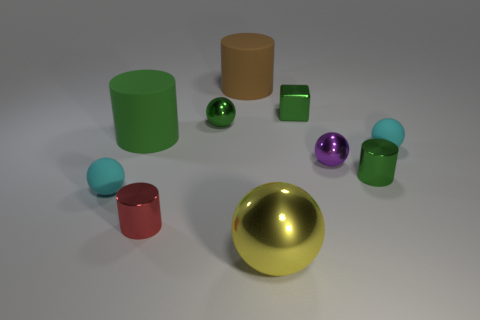The yellow metallic thing has what size?
Ensure brevity in your answer.  Large. There is a cyan object to the left of the red shiny thing; what shape is it?
Ensure brevity in your answer.  Sphere. Do the tiny red metallic thing and the big brown matte thing have the same shape?
Your answer should be compact. Yes. Is the number of tiny red things that are behind the green shiny ball the same as the number of small gray metallic things?
Your response must be concise. Yes. The green matte object has what shape?
Provide a succinct answer. Cylinder. Is there any other thing of the same color as the large sphere?
Provide a short and direct response. No. Do the matte sphere that is to the left of the large sphere and the yellow metal sphere that is in front of the big green cylinder have the same size?
Ensure brevity in your answer.  No. There is a big thing in front of the metallic cylinder on the right side of the large yellow metal object; what shape is it?
Your response must be concise. Sphere. Do the green rubber thing and the cyan rubber thing left of the brown matte cylinder have the same size?
Make the answer very short. No. There is a shiny cylinder that is on the right side of the tiny cylinder that is in front of the matte sphere that is left of the tiny purple object; how big is it?
Give a very brief answer. Small. 